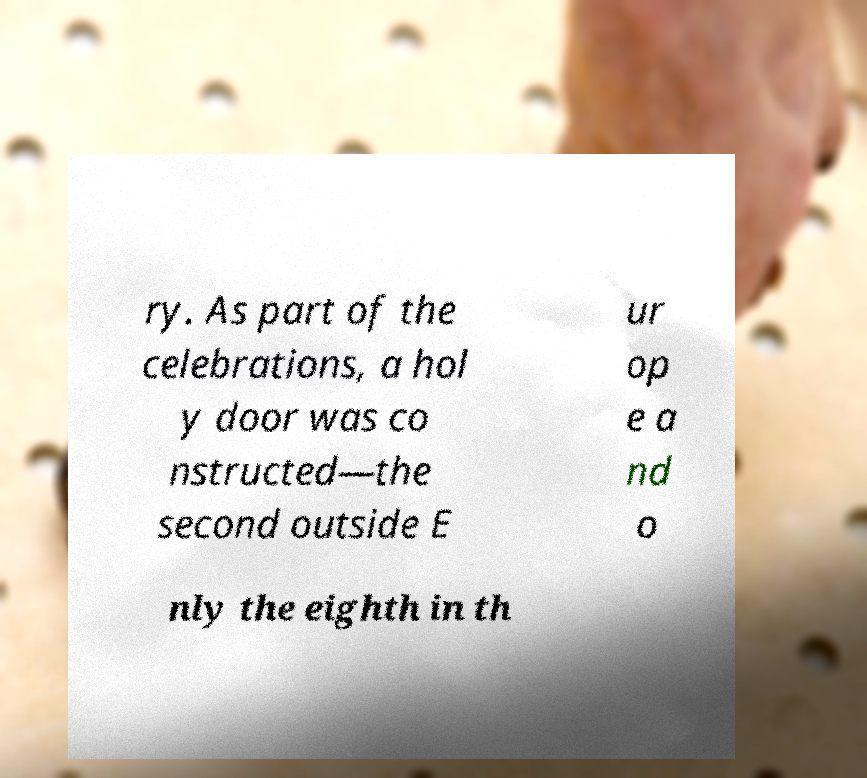For documentation purposes, I need the text within this image transcribed. Could you provide that? ry. As part of the celebrations, a hol y door was co nstructed—the second outside E ur op e a nd o nly the eighth in th 